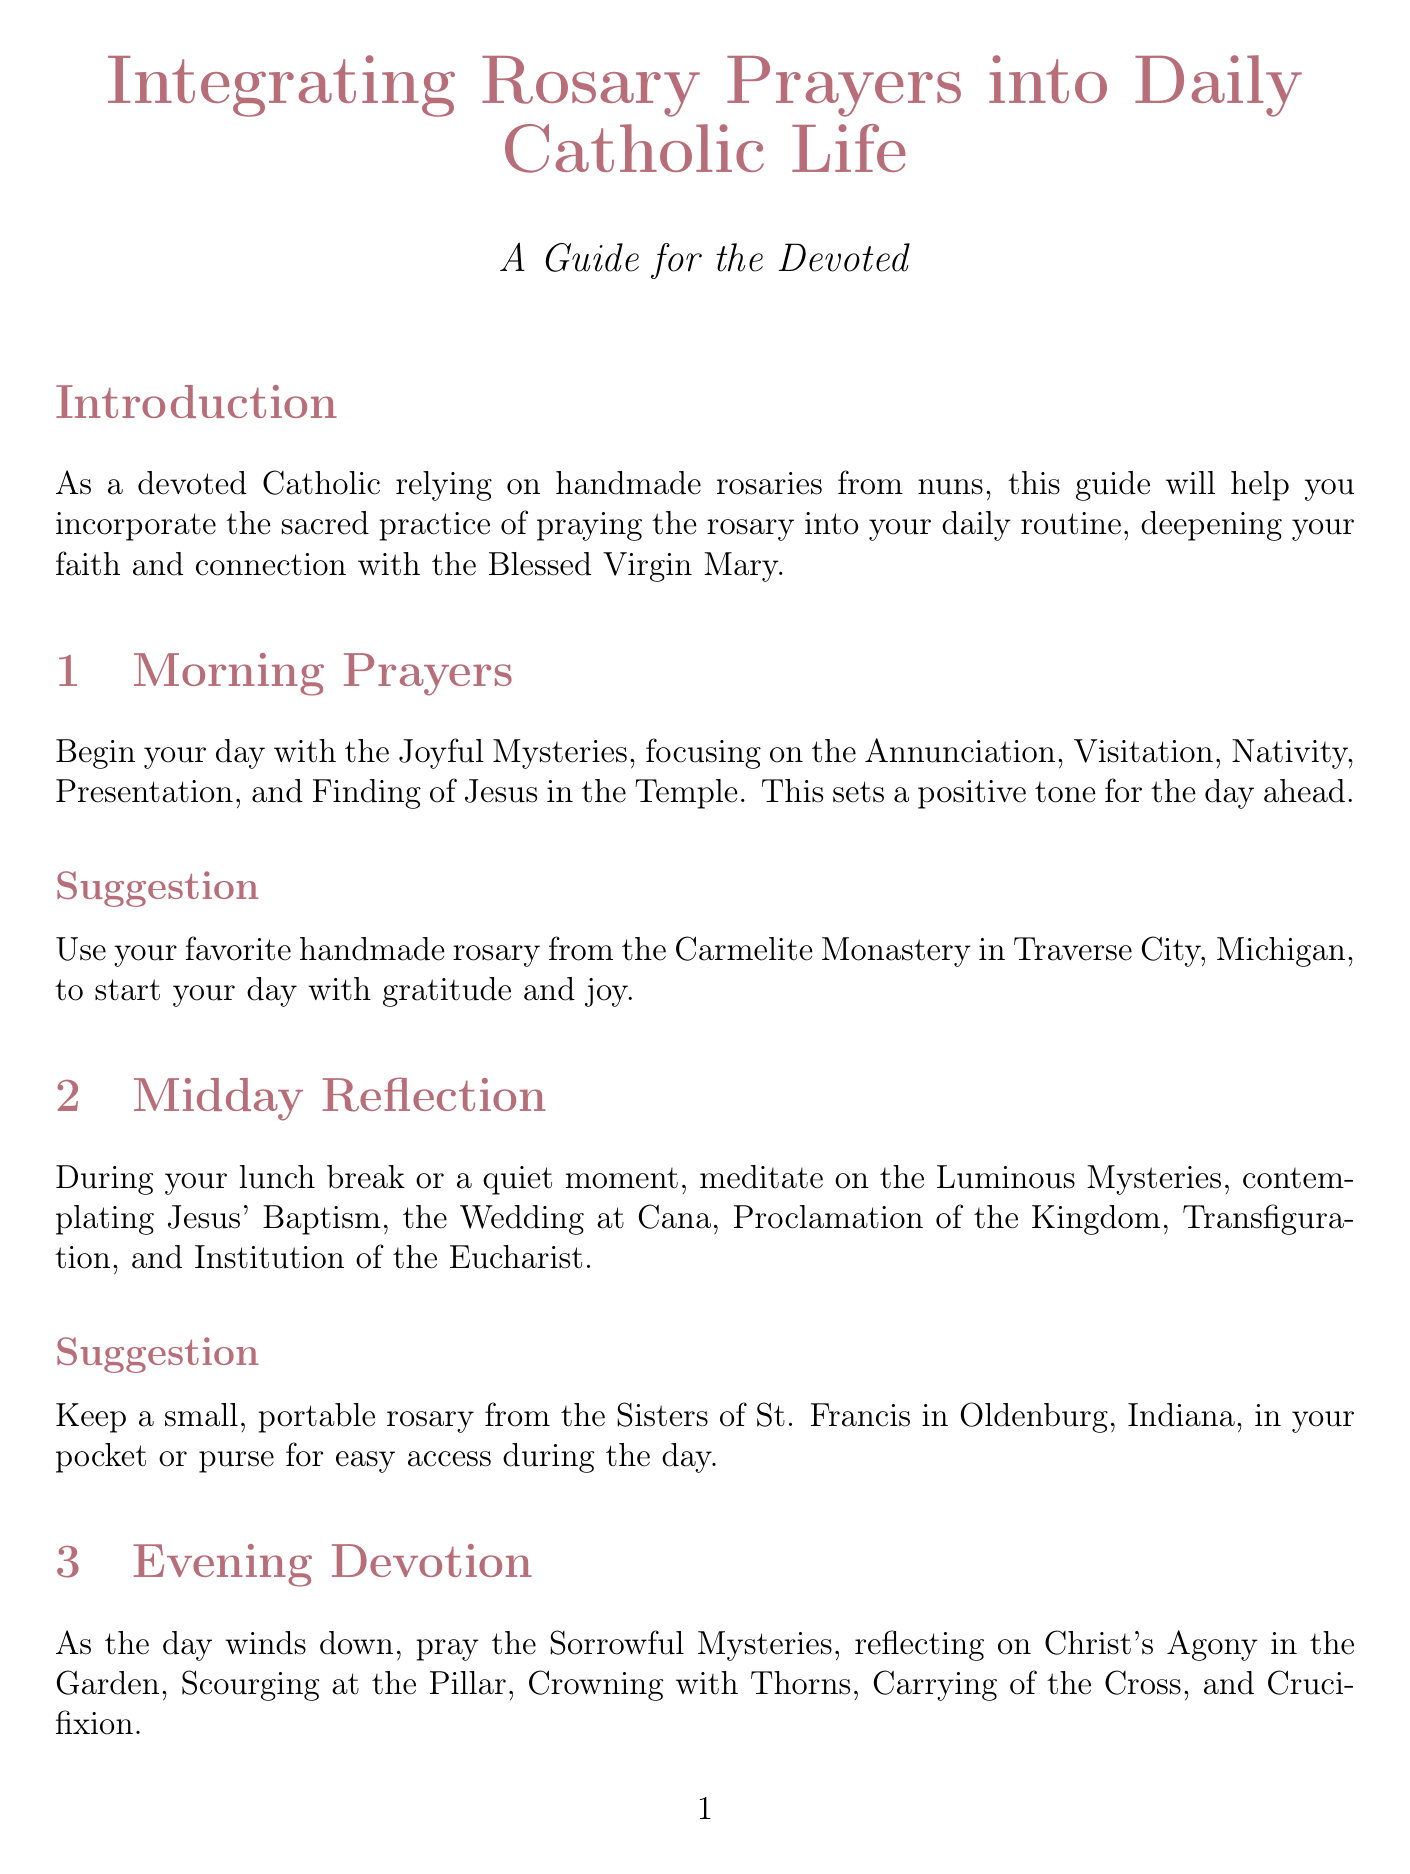What are the Joyful Mysteries? The Joyful Mysteries include the Annunciation, Visitation, Nativity, Presentation, and Finding of Jesus in the Temple, which are mentioned in the Morning Prayers section.
Answer: Annunciation, Visitation, Nativity, Presentation, Finding of Jesus in the Temple Where can you find a portable rosary suggestion? The document suggests keeping a portable rosary from the Sisters of St. Francis in Oldenburg, Indiana, for easy access during the day, mentioned in the Midday Reflection section.
Answer: Sisters of St. Francis in Oldenburg, Indiana What is the intention for Monday? The document states that Monday's intention is for the souls in Purgatory as listed in the Special Intentions section.
Answer: For the souls in Purgatory Which rosary is recommended for night prayers? The suggested rosary for night prayers before bed is a glow-in-the-dark rosary made by the Benedictine Sisters of Perpetual Adoration in Clyde, Missouri.
Answer: Glow-in-the-dark rosary by the Benedictine Sisters of Perpetual Adoration in Clyde, Missouri How many special intentions are listed? The document outlines seven special intentions dedicated to specific days of the week in the Special Intentions section.
Answer: Seven 